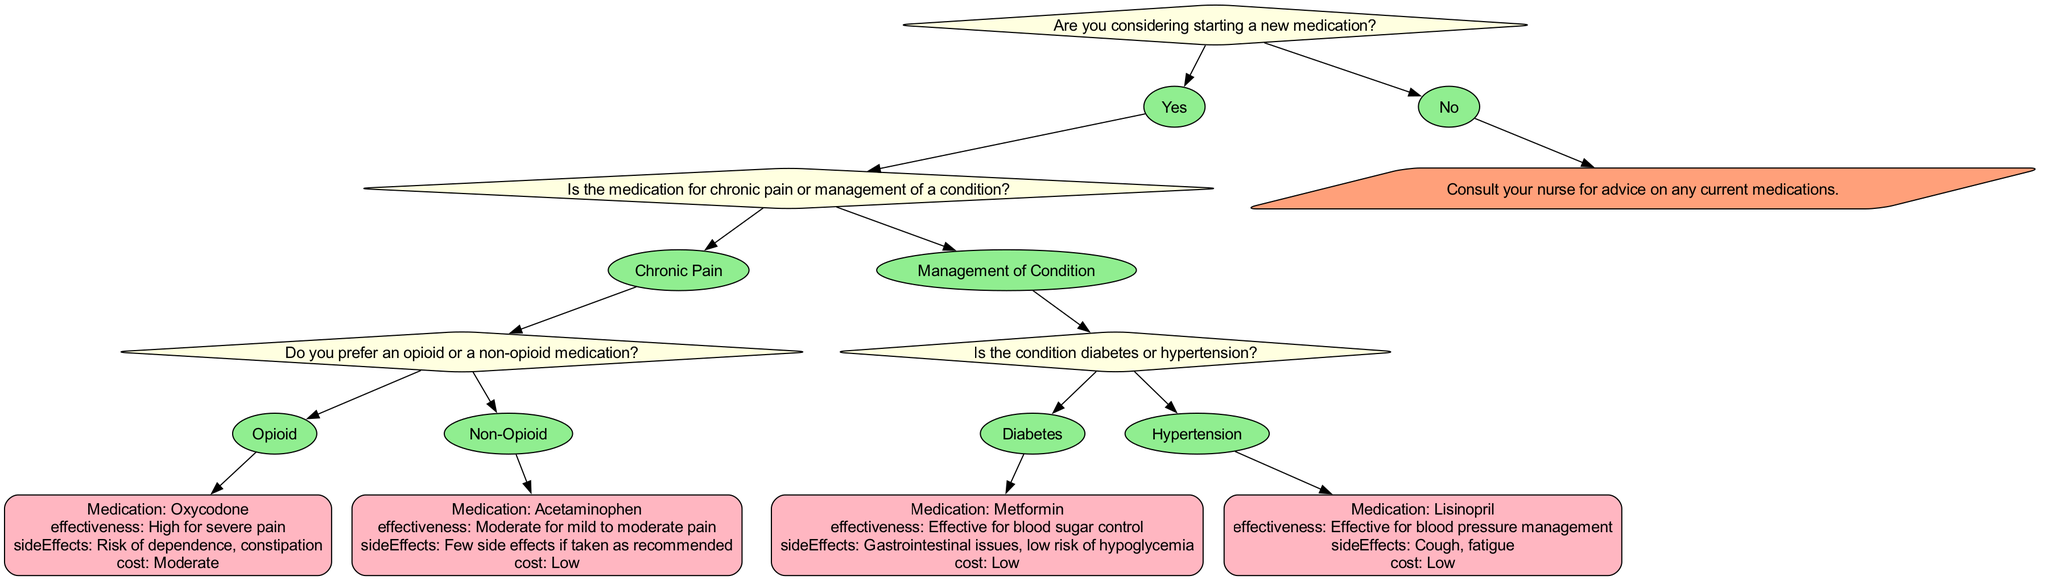Are you considering starting a new medication? The starting question in the diagram is whether the patient is considering starting a new medication. This is the first decision point, specifically addressing the initial consideration before exploring medication options.
Answer: Yes What is the effectiveness of Acetaminophen? The diagram details that Acetaminophen has a moderate effectiveness for mild to moderate pain. This specific medication is reached through following the path of non-opioid medication for chronic pain.
Answer: Moderate for mild to moderate pain Which medication is suggested for diabetes? The decision tree specifies Metformin as the medication recommended for managing diabetes. This is reached when the decision is made that the condition is diabetes under the management of a condition branch.
Answer: Metformin What side effect is associated with Lisinopril? According to the tree, Lisinopril has side effects including cough and fatigue, which are stated in the considerations for the medication once hypertension is selected as the condition to be managed.
Answer: Cough, fatigue If you prefer a non-opioid medication for chronic pain, what is the cost of Acetaminophen? Following the decision path for non-opioid medication leads to Acetaminophen, which has a low cost in the diagram. This shows that opting for a non-opioid medication is cost-effective.
Answer: Low What happens if the answer to starting a new medication is no? The diagram indicates that if the answer is no, the patient is advised to consult their nurse for advice on current medications, providing a clear guideline for this scenario.
Answer: Consult your nurse for advice on any current medications 